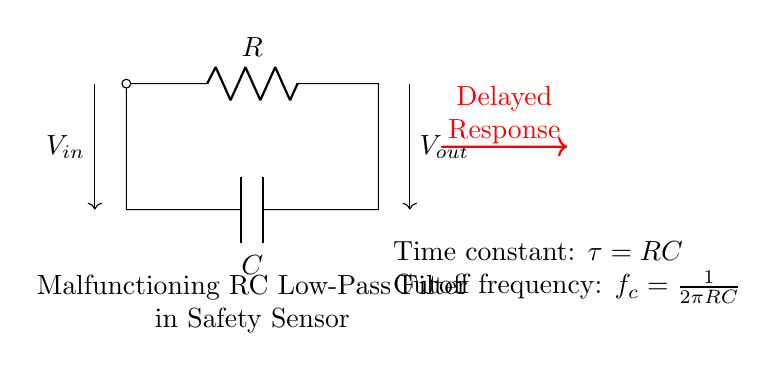What components make up this circuit? The circuit consists of a resistor (R) and a capacitor (C) connected in a parallel configuration, forming an RC low-pass filter.
Answer: Resistor and capacitor What is the purpose of the arrow labeled Vout? The arrow labeled Vout indicates the output voltage of the circuit, which is taken across the capacitor in the RC low-pass filter arrangement.
Answer: Output voltage What happens to the response time when the resistance or capacitance increases? Increasing either the resistance or capacitance increases the time constant (tau), which leads to a slower response time in the safety sensor due to longer charge and discharge times.
Answer: Slower response What is the time constant of this RC circuit? The time constant (tau) is the product of the resistance (R) and capacitance (C) in the circuit; specifically, tau equals R multiplied by C.
Answer: RC What is the cutoff frequency for an RC low-pass filter? The cutoff frequency (fc) is determined by the formula fc equals one over two pi times RC, representing the frequency at which the output voltage is reduced to 70.7 percent of the input voltage.
Answer: One over two pi RC How does the delayed response affect safety sensor functionality? A delayed response can lead to slower detection or response to potentially hazardous situations, which undermines the safety function of the sensor.
Answer: Unsafe operation What circuit behavior is likely indicated by the term "malfunctioning" in this context? "Malfunctioning" suggests that the RC low-pass filter is not operating correctly, possibly leading to excessive delays or incorrect filtering of the input signal, thus affecting sensor performance.
Answer: Incorrect filtering 